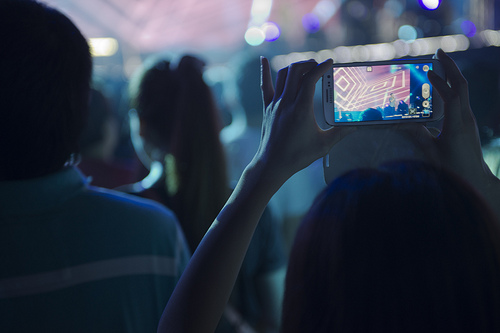<image>
Is there a woman on the mobile? Yes. Looking at the image, I can see the woman is positioned on top of the mobile, with the mobile providing support. 